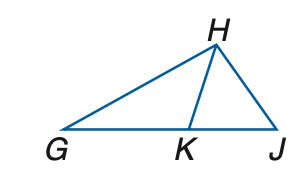Answer the mathemtical geometry problem and directly provide the correct option letter.
Question: In the figure, G K \cong G H and H K \cong K J. If m \angle H G K = 28, find m \angle H J K.
Choices: A: 38 B: 42 C: 46 D: 56 A 